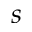Convert formula to latex. <formula><loc_0><loc_0><loc_500><loc_500>s</formula> 